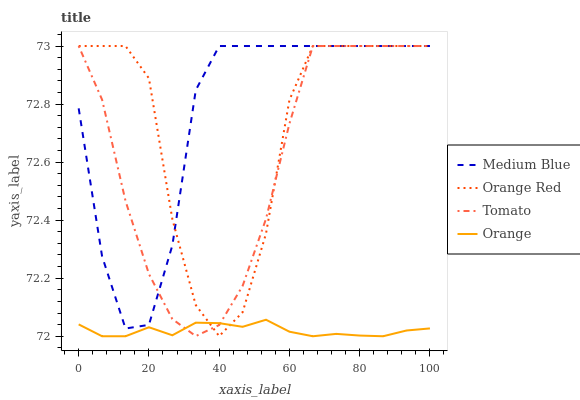Does Orange have the minimum area under the curve?
Answer yes or no. Yes. Does Medium Blue have the maximum area under the curve?
Answer yes or no. Yes. Does Medium Blue have the minimum area under the curve?
Answer yes or no. No. Does Orange have the maximum area under the curve?
Answer yes or no. No. Is Orange the smoothest?
Answer yes or no. Yes. Is Orange Red the roughest?
Answer yes or no. Yes. Is Medium Blue the smoothest?
Answer yes or no. No. Is Medium Blue the roughest?
Answer yes or no. No. Does Orange have the lowest value?
Answer yes or no. Yes. Does Medium Blue have the lowest value?
Answer yes or no. No. Does Orange Red have the highest value?
Answer yes or no. Yes. Does Orange have the highest value?
Answer yes or no. No. Is Orange less than Medium Blue?
Answer yes or no. Yes. Is Medium Blue greater than Orange?
Answer yes or no. Yes. Does Orange Red intersect Medium Blue?
Answer yes or no. Yes. Is Orange Red less than Medium Blue?
Answer yes or no. No. Is Orange Red greater than Medium Blue?
Answer yes or no. No. Does Orange intersect Medium Blue?
Answer yes or no. No. 